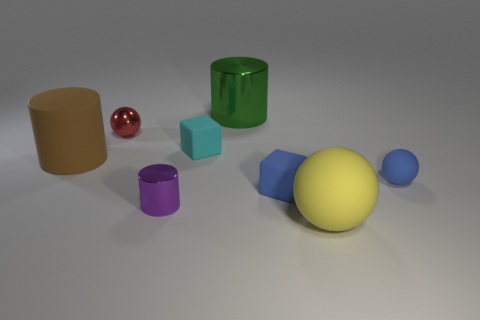There is a rubber block that is the same color as the tiny matte ball; what size is it?
Your response must be concise. Small. Is there a large metal object of the same shape as the tiny purple thing?
Keep it short and to the point. Yes. What is the color of the shiny cylinder that is the same size as the matte cylinder?
Offer a very short reply. Green. Is the number of big brown cylinders that are right of the small purple metal thing less than the number of large green metallic cylinders that are on the left side of the big green metal thing?
Your answer should be very brief. No. Does the rubber sphere that is behind the blue block have the same size as the tiny red sphere?
Your answer should be very brief. Yes. What shape is the tiny shiny thing in front of the big brown cylinder?
Provide a short and direct response. Cylinder. Is the number of small cylinders greater than the number of small gray metal things?
Offer a terse response. Yes. There is a thing right of the yellow sphere; is its color the same as the rubber cylinder?
Provide a short and direct response. No. What number of objects are small spheres in front of the small red sphere or small metallic things behind the large brown cylinder?
Offer a very short reply. 2. How many metal things are both in front of the small cyan matte block and to the left of the purple metal object?
Offer a very short reply. 0. 